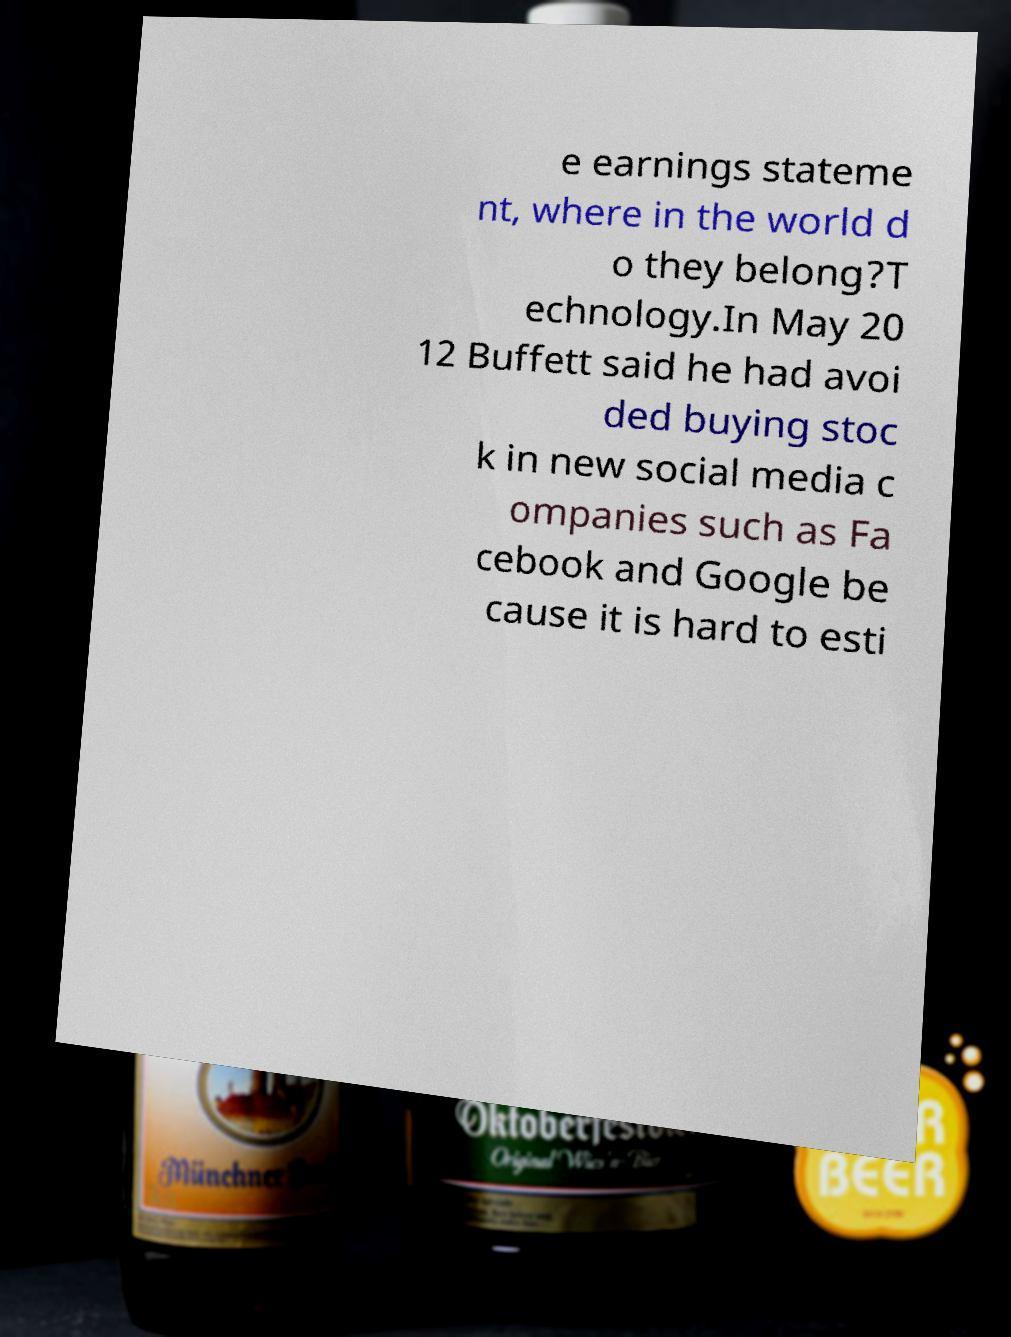I need the written content from this picture converted into text. Can you do that? e earnings stateme nt, where in the world d o they belong?T echnology.In May 20 12 Buffett said he had avoi ded buying stoc k in new social media c ompanies such as Fa cebook and Google be cause it is hard to esti 